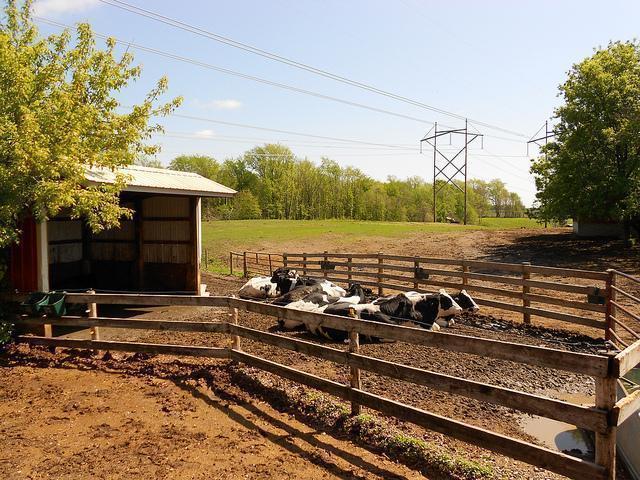What is the large structure in the background?
Pick the correct solution from the four options below to address the question.
Options: Power lines, business, skyscraper, stadium. Power lines. 